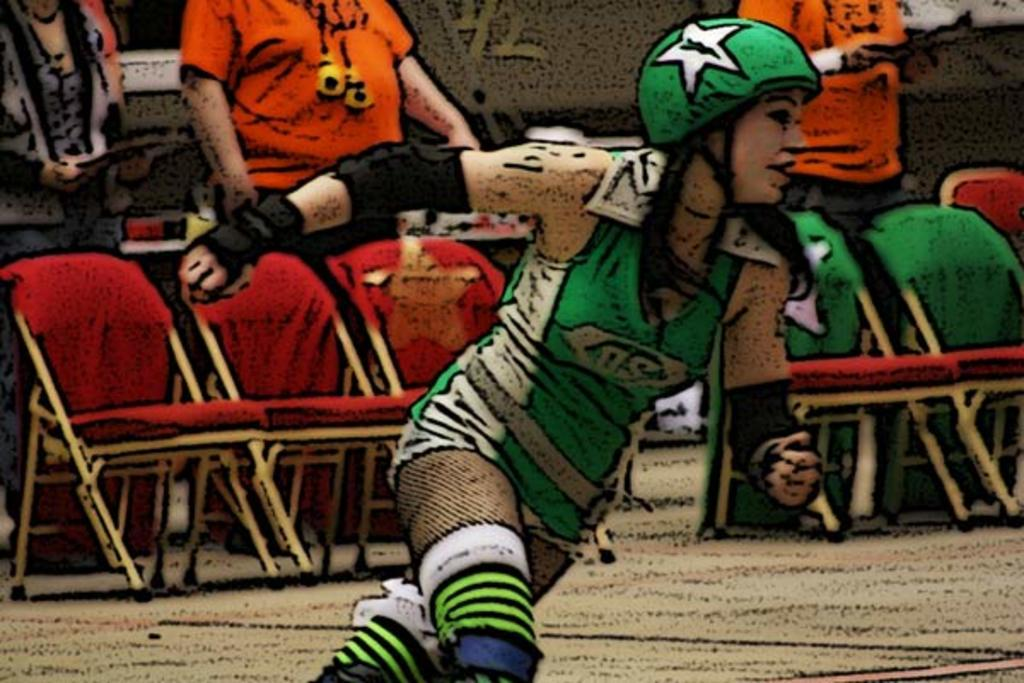What is the woman in the image doing? The woman is running in the image. On what surface is the woman running? The woman is running on a ground. What can be seen in the background of the image? There are chairs and three persons standing in the background of the image. What type of iron is being used by the woman in the image? There is no iron present in the image; the woman is running. What day of the week is depicted in the image? The day of the week is not mentioned or depicted in the image. 